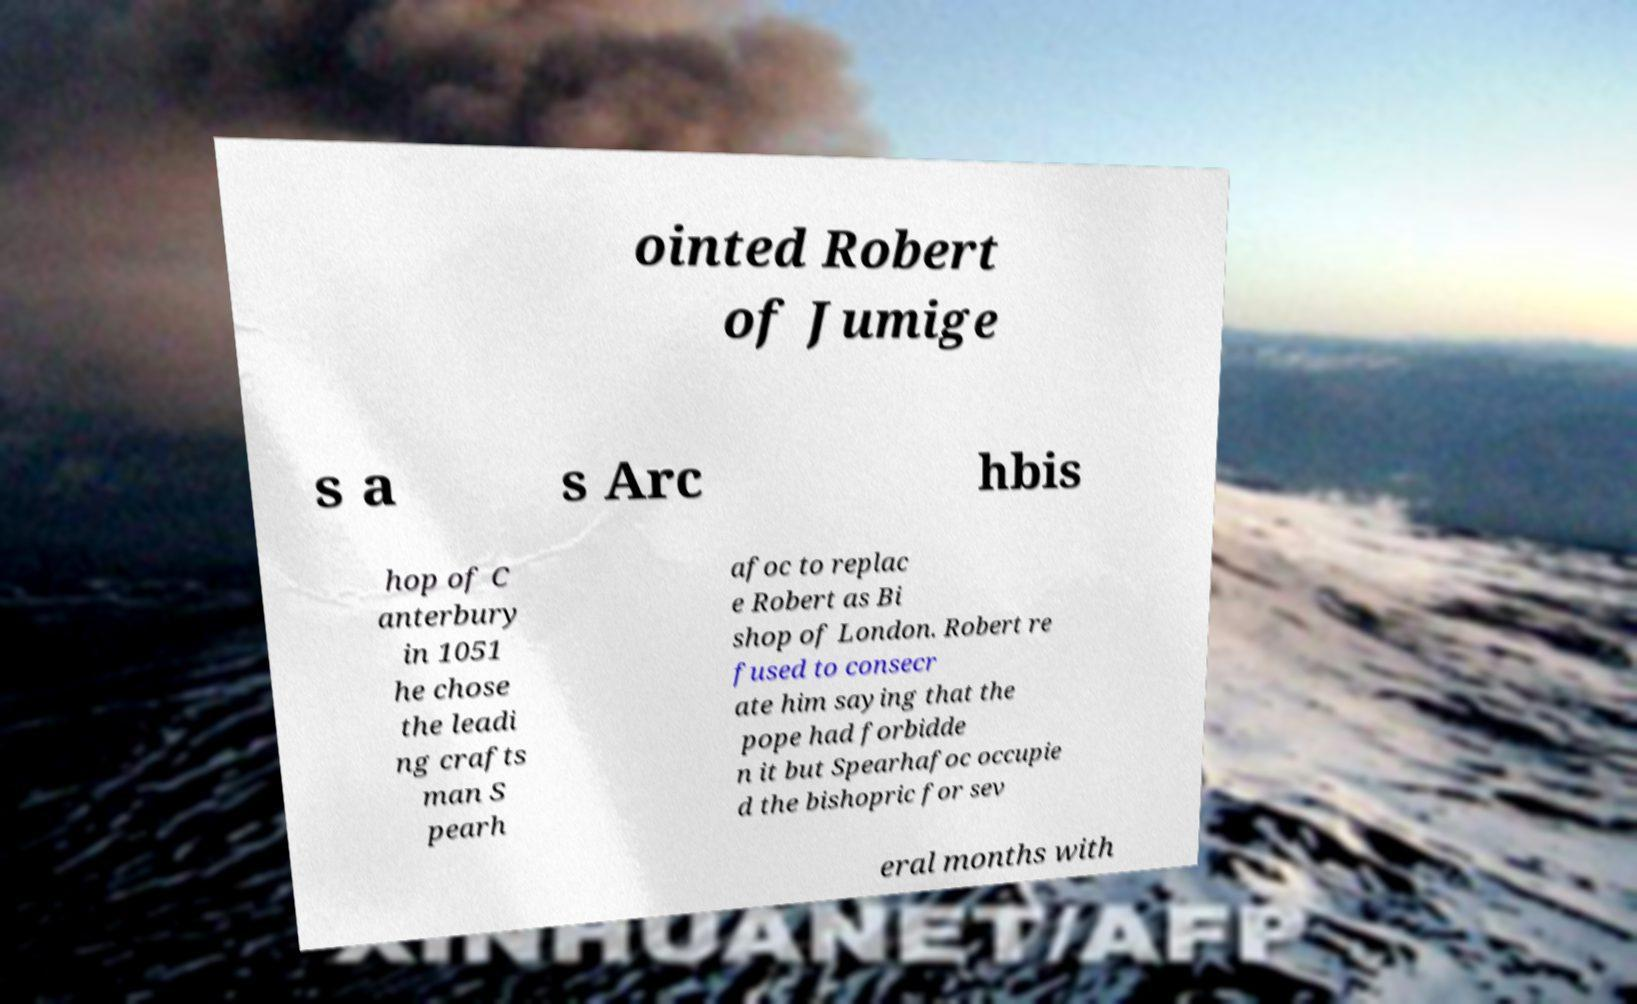Can you accurately transcribe the text from the provided image for me? ointed Robert of Jumige s a s Arc hbis hop of C anterbury in 1051 he chose the leadi ng crafts man S pearh afoc to replac e Robert as Bi shop of London. Robert re fused to consecr ate him saying that the pope had forbidde n it but Spearhafoc occupie d the bishopric for sev eral months with 